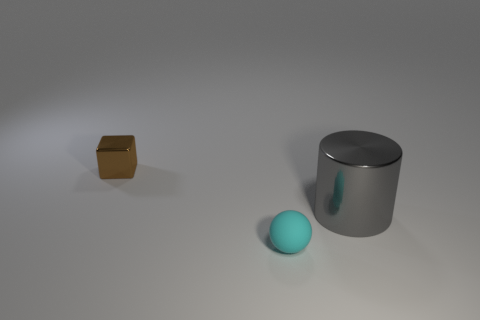Add 2 small brown objects. How many objects exist? 5 Subtract all blocks. How many objects are left? 2 Subtract 0 green blocks. How many objects are left? 3 Subtract all purple matte balls. Subtract all gray things. How many objects are left? 2 Add 1 big metallic cylinders. How many big metallic cylinders are left? 2 Add 2 large gray metallic objects. How many large gray metallic objects exist? 3 